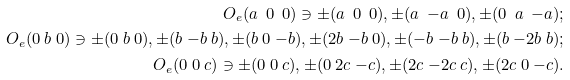Convert formula to latex. <formula><loc_0><loc_0><loc_500><loc_500>O _ { e } ( a \ 0 \ 0 ) \ni \pm ( a \ 0 \ 0 ) , \pm ( a \ { - } a \ 0 ) , \pm ( 0 \ a \ { - } a ) ; \\ O _ { e } ( 0 \ b \ 0 ) \ni \pm ( 0 \ b \ 0 ) , \pm ( b \ { - } b \ b ) , \pm ( b \ 0 \ { - } b ) , \pm ( 2 b \ { - } b \ 0 ) , \pm ( { - } b \ { - } b \ b ) , \pm ( b \ { - } 2 b \ b ) ; \\ O _ { e } ( 0 \ 0 \ c ) \ni \pm ( 0 \ 0 \ c ) , \pm ( 0 \ 2 c \ { - } c ) , \pm ( 2 c \ { - } 2 c \ c ) , \pm ( 2 c \ 0 \ { - } c ) .</formula> 